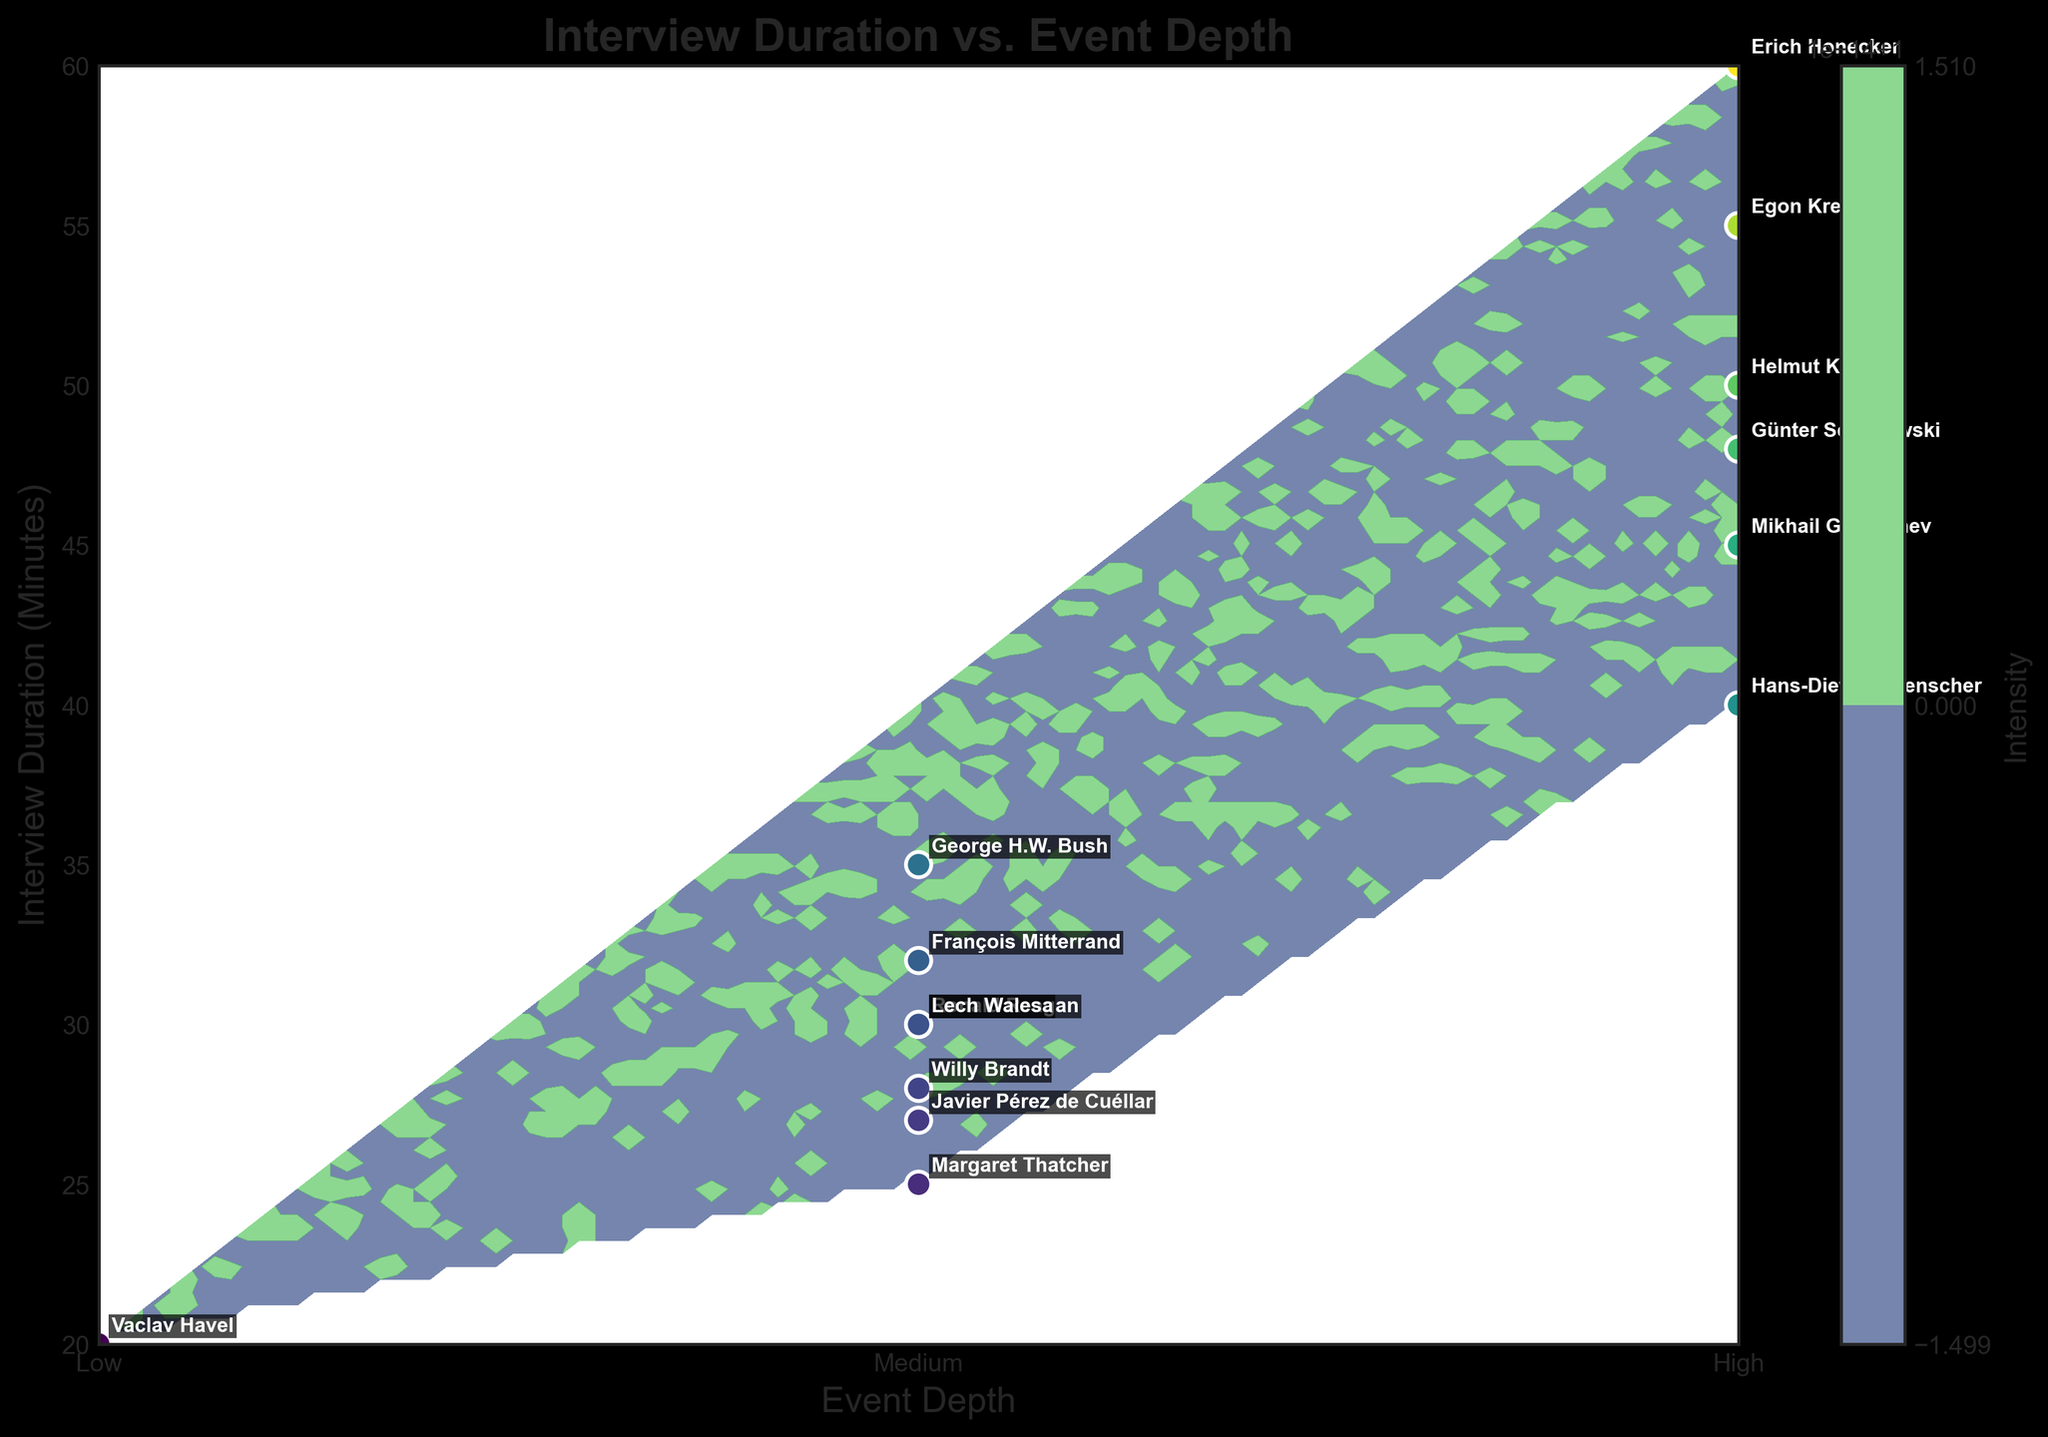What is the title of the figure? The title is always found at the top of the figure and it is meant to summarize the overall subject of the plot. In this case, it clearly states "Interview Duration vs. Event Depth"
Answer: Interview Duration vs. Event Depth How many data points are plotted? By counting the individual scatter points on the plot, we can determine the number of data points. There are 14 discernible points, each representing an interview with one of the political figures.
Answer: 14 What is the color scheme used for the contour plot? The color scheme can be identified from the color gradient and the colorbar. Here, a "viridis" colormap is used, which generally ranges from purples to greens to yellows.
Answer: viridis Which interviewee has the longest interview duration and what is that duration? By looking at the y-axis and identifying the highest point along with its label, we can see that Erich Honecker has the longest interview duration at 60 minutes.
Answer: Erich Honecker, 60 minutes Compare the interview durations of Mikhail Gorbachev and Ronald Reagan. Mikhail Gorbachev's duration is 45 minutes (high depth), and Ronald Reagan's is 30 minutes (medium depth). This means Gorbachev's interview duration is 15 minutes longer than Reagan's.
Answer: Gorbachev's is 15 minutes longer What is the range of interview durations for figures with high event depth? Analyzing the scattered points labeled "High" on the x-axis, their y-values range from 40 to 60 minutes. The figures within high event depth group encompass a span of 20 minutes.
Answer: 20 minutes What does the x-axis represent and what are its tick labels? The x-axis represents event depth, and the labels indicate the levels of involvement: Low, Medium, and High.
Answer: Event Depth; Low, Medium, High How does the interview duration vary across different event depths? Observing the y-axis values across the x-axis depth levels, interview durations are higher on average for "High" and lower for "Low." Medium-depth figures generally have intermediate durations.
Answer: Higher for "High," intermediate for "Medium," lower for "Low" Which political figures have medium event depth and appear in the middle range of interview durations? From the plot, Ronald Reagan, Margaret Thatcher, George H.W. Bush, Lech Walesa, Willy Brandt, and François Mitterrand, all in the 25-35 minute range. This is confirmed by checking the middle x-axis labels for "Medium."
Answer: Reagan, Thatcher, Bush, Walesa, Brandt, Mitterrand 